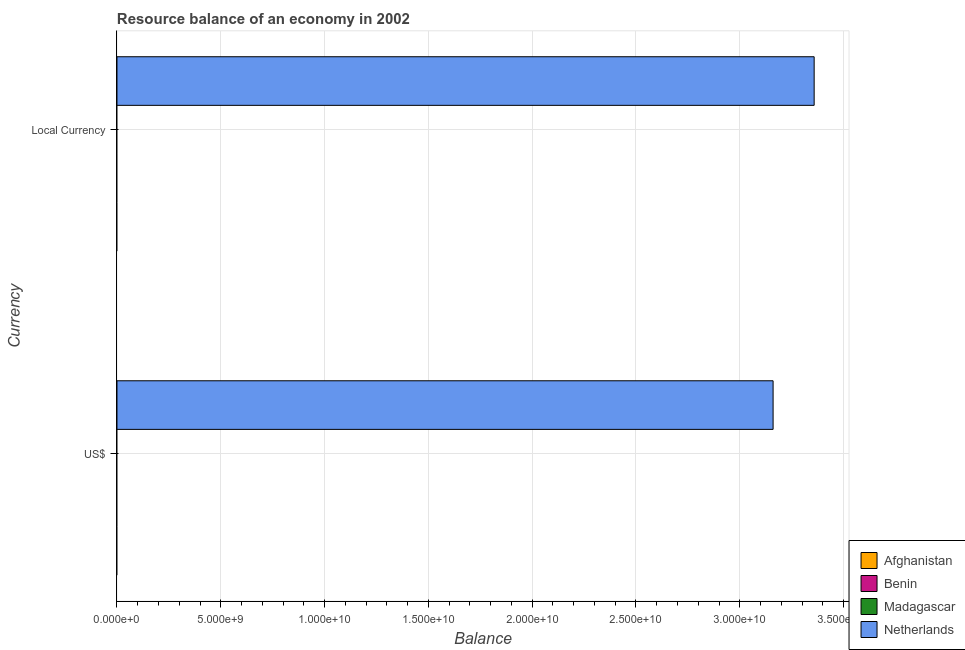How many different coloured bars are there?
Offer a very short reply. 1. Are the number of bars on each tick of the Y-axis equal?
Offer a terse response. Yes. How many bars are there on the 2nd tick from the top?
Your answer should be compact. 1. How many bars are there on the 2nd tick from the bottom?
Provide a short and direct response. 1. What is the label of the 1st group of bars from the top?
Your answer should be compact. Local Currency. Across all countries, what is the maximum resource balance in constant us$?
Your response must be concise. 3.36e+1. Across all countries, what is the minimum resource balance in us$?
Your answer should be compact. 0. In which country was the resource balance in us$ maximum?
Your answer should be compact. Netherlands. What is the total resource balance in us$ in the graph?
Offer a terse response. 3.16e+1. What is the average resource balance in us$ per country?
Offer a terse response. 7.90e+09. What is the difference between the resource balance in constant us$ and resource balance in us$ in Netherlands?
Provide a succinct answer. 1.98e+09. In how many countries, is the resource balance in us$ greater than 1000000000 units?
Keep it short and to the point. 1. How many countries are there in the graph?
Ensure brevity in your answer.  4. What is the difference between two consecutive major ticks on the X-axis?
Make the answer very short. 5.00e+09. Does the graph contain any zero values?
Offer a terse response. Yes. Does the graph contain grids?
Provide a succinct answer. Yes. Where does the legend appear in the graph?
Your answer should be compact. Bottom right. How many legend labels are there?
Offer a very short reply. 4. How are the legend labels stacked?
Your answer should be compact. Vertical. What is the title of the graph?
Your answer should be compact. Resource balance of an economy in 2002. What is the label or title of the X-axis?
Provide a short and direct response. Balance. What is the label or title of the Y-axis?
Your response must be concise. Currency. What is the Balance in Afghanistan in US$?
Make the answer very short. 0. What is the Balance in Madagascar in US$?
Your answer should be compact. 0. What is the Balance in Netherlands in US$?
Provide a succinct answer. 3.16e+1. What is the Balance of Madagascar in Local Currency?
Your answer should be compact. 0. What is the Balance of Netherlands in Local Currency?
Provide a succinct answer. 3.36e+1. Across all Currency, what is the maximum Balance in Netherlands?
Offer a terse response. 3.36e+1. Across all Currency, what is the minimum Balance in Netherlands?
Give a very brief answer. 3.16e+1. What is the total Balance of Netherlands in the graph?
Offer a terse response. 6.52e+1. What is the difference between the Balance of Netherlands in US$ and that in Local Currency?
Your answer should be compact. -1.98e+09. What is the average Balance in Afghanistan per Currency?
Ensure brevity in your answer.  0. What is the average Balance of Benin per Currency?
Keep it short and to the point. 0. What is the average Balance of Madagascar per Currency?
Your response must be concise. 0. What is the average Balance of Netherlands per Currency?
Your response must be concise. 3.26e+1. What is the ratio of the Balance of Netherlands in US$ to that in Local Currency?
Your response must be concise. 0.94. What is the difference between the highest and the second highest Balance of Netherlands?
Your response must be concise. 1.98e+09. What is the difference between the highest and the lowest Balance of Netherlands?
Keep it short and to the point. 1.98e+09. 